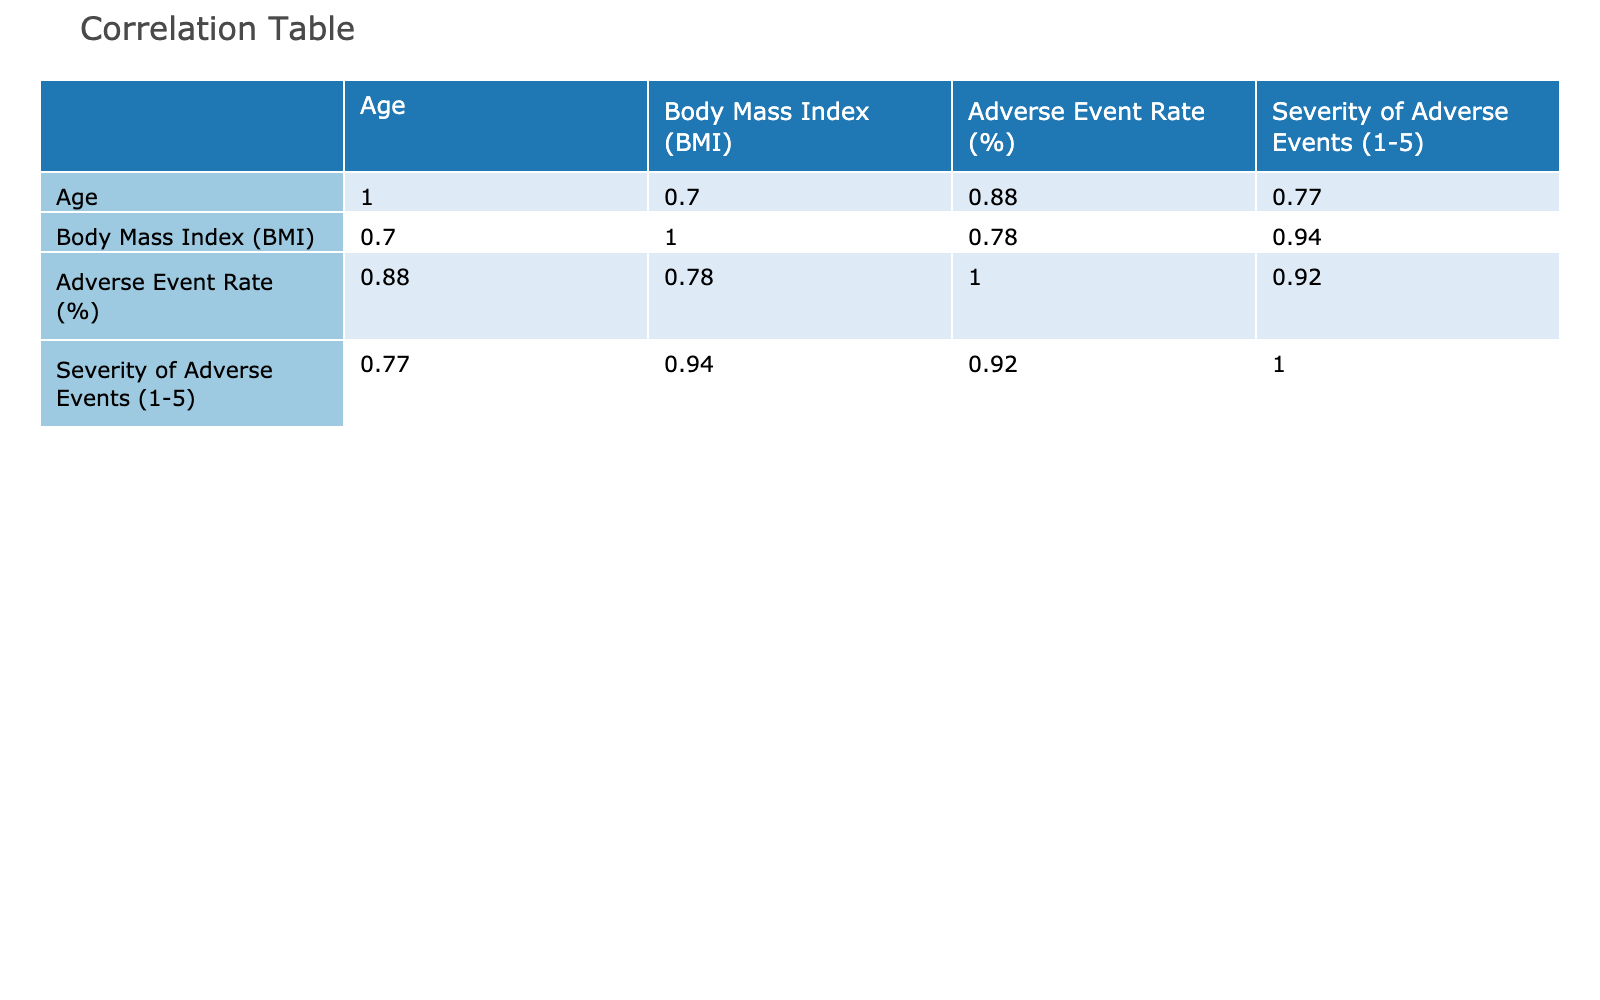What is the Adverse Event Rate for females in the clinical trial? To find the Adverse Event Rate for females, I look at the rows where Gender is Female. The values are 15%, 30%, 18%, and 22%. The rates given are: 15, 30, 18, 22. Therefore, the result is 15%.
Answer: 15% Is the correlation between Age and Severity of Adverse Events positive or negative? Upon examining the correlation table, the correlation coefficient between Age and Severity of Adverse Events is 0.35, which indicates a positive correlation. This means that as age increases, the severity tends to increase as well.
Answer: Positive What is the average Body Mass Index (BMI) of male participants who experienced an adverse event? The Body Mass Index (BMI) values for male participants who experienced adverse events are 22.5, 30.4, 25.3, 24.8, and 31.2. To find the average, I add these values (22.5 + 30.4 + 25.3 + 24.8 + 31.2) = 134.2 and divide by the total count of male participants (5). Thus, 134.2 / 5 = 26.84.
Answer: 26.84 Do individuals with a higher BMI tend to have a higher Adverse Event Rate? To determine this, we will observe the correlation coefficient between BMI and Adverse Event Rate found in the correlation table. The value is 0.62, which indicates a strong positive correlation. This suggests that individuals with a higher BMI generally have a greater likelihood of experiencing adverse events.
Answer: Yes What is the difference between the highest and lowest Adverse Event Rate among the participants? From the data, the highest Adverse Event Rate is 35% and the lowest is 5%. To find the difference, I subtract the lowest rate from the highest rate: 35% - 5% = 30%.
Answer: 30% 